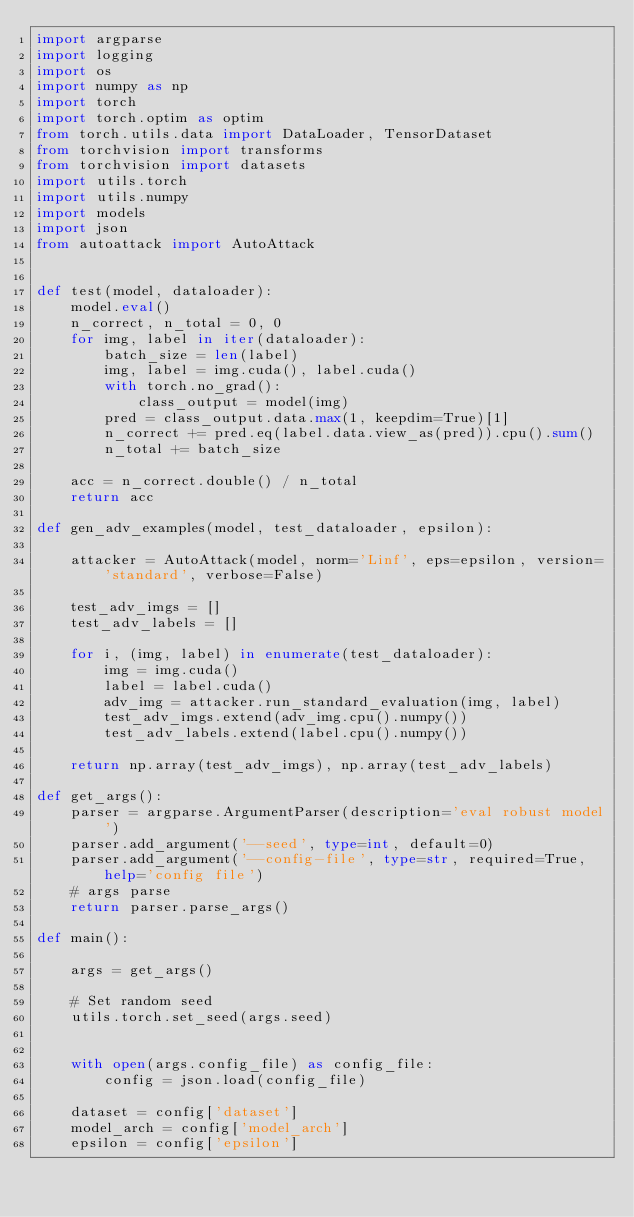<code> <loc_0><loc_0><loc_500><loc_500><_Python_>import argparse
import logging
import os
import numpy as np
import torch
import torch.optim as optim
from torch.utils.data import DataLoader, TensorDataset
from torchvision import transforms
from torchvision import datasets
import utils.torch
import utils.numpy
import models
import json
from autoattack import AutoAttack


def test(model, dataloader):
    model.eval()
    n_correct, n_total = 0, 0
    for img, label in iter(dataloader):
        batch_size = len(label)
        img, label = img.cuda(), label.cuda()
        with torch.no_grad():
            class_output = model(img)
        pred = class_output.data.max(1, keepdim=True)[1]
        n_correct += pred.eq(label.data.view_as(pred)).cpu().sum()
        n_total += batch_size

    acc = n_correct.double() / n_total
    return acc

def gen_adv_examples(model, test_dataloader, epsilon):

    attacker = AutoAttack(model, norm='Linf', eps=epsilon, version='standard', verbose=False)

    test_adv_imgs = []
    test_adv_labels = []

    for i, (img, label) in enumerate(test_dataloader):
        img = img.cuda()
        label = label.cuda()
        adv_img = attacker.run_standard_evaluation(img, label)
        test_adv_imgs.extend(adv_img.cpu().numpy())
        test_adv_labels.extend(label.cpu().numpy())

    return np.array(test_adv_imgs), np.array(test_adv_labels)

def get_args():
    parser = argparse.ArgumentParser(description='eval robust model')
    parser.add_argument('--seed', type=int, default=0)
    parser.add_argument('--config-file', type=str, required=True, help='config file')
    # args parse
    return parser.parse_args()

def main():

    args = get_args()
    
    # Set random seed
    utils.torch.set_seed(args.seed)
    
    
    with open(args.config_file) as config_file:
        config = json.load(config_file)

    dataset = config['dataset']
    model_arch = config['model_arch']
    epsilon = config['epsilon']</code> 